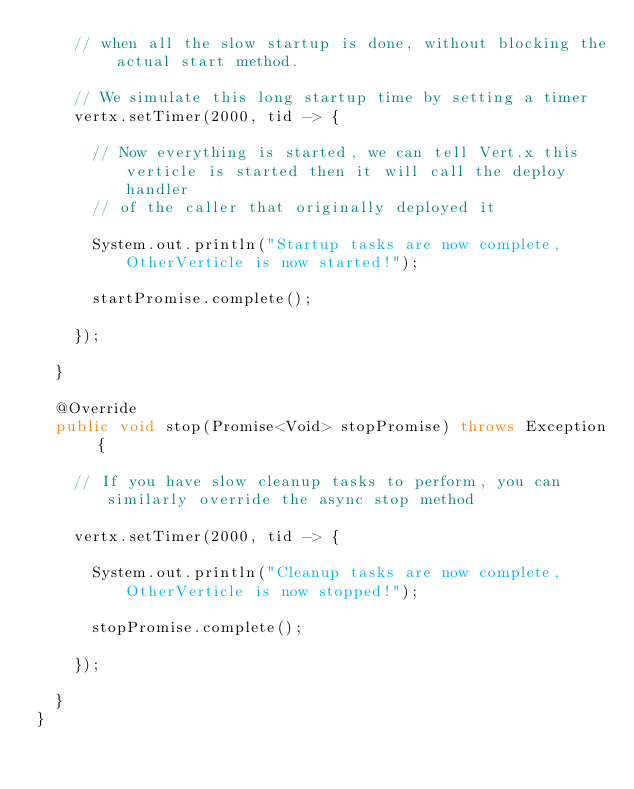<code> <loc_0><loc_0><loc_500><loc_500><_Java_>    // when all the slow startup is done, without blocking the actual start method.

    // We simulate this long startup time by setting a timer
    vertx.setTimer(2000, tid -> {

      // Now everything is started, we can tell Vert.x this verticle is started then it will call the deploy handler
      // of the caller that originally deployed it

      System.out.println("Startup tasks are now complete, OtherVerticle is now started!");

      startPromise.complete();

    });

  }

  @Override
  public void stop(Promise<Void> stopPromise) throws Exception {

    // If you have slow cleanup tasks to perform, you can similarly override the async stop method

    vertx.setTimer(2000, tid -> {

      System.out.println("Cleanup tasks are now complete, OtherVerticle is now stopped!");

      stopPromise.complete();

    });

  }
}
</code> 